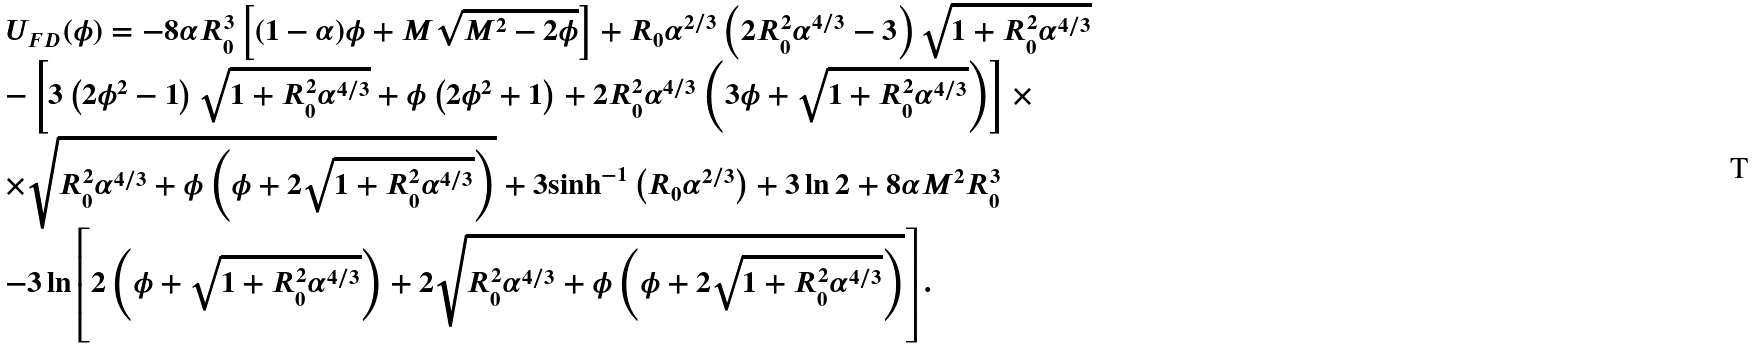Convert formula to latex. <formula><loc_0><loc_0><loc_500><loc_500>\begin{array} { l } { U _ { F D } } ( \phi ) = - 8 \alpha { R _ { 0 } ^ { 3 } } \left [ { ( 1 - \alpha ) \phi + M \sqrt { { M ^ { 2 } } - 2 \phi } } \right ] + R _ { 0 } { \alpha ^ { 2 / 3 } } \left ( { 2 { R _ { 0 } ^ { 2 } } { \alpha ^ { 4 / 3 } } - 3 } \right ) \sqrt { 1 + { R _ { 0 } ^ { 2 } } { \alpha ^ { 4 / 3 } } } \\ - \left [ { 3 \left ( { 2 { \phi ^ { 2 } } - 1 } \right ) \sqrt { 1 + { R _ { 0 } ^ { 2 } } { \alpha ^ { 4 / 3 } } } + \phi \left ( { 2 { \phi ^ { 2 } } + 1 } \right ) + 2 { R _ { 0 } ^ { 2 } } { \alpha ^ { 4 / 3 } } \left ( { 3 \phi + \sqrt { 1 + { R _ { 0 } ^ { 2 } } { \alpha ^ { 4 / 3 } } } } \right ) } \right ] \times \\ \times \sqrt { { R _ { 0 } ^ { 2 } } { \alpha ^ { 4 / 3 } } + \phi \left ( { \phi + 2 \sqrt { 1 + { R _ { 0 } ^ { 2 } } { \alpha ^ { 4 / 3 } } } } \right ) } + 3 { \sinh ^ { - 1 } } \left ( { R _ { 0 } { \alpha ^ { 2 / 3 } } } \right ) + 3 \ln 2 + 8 \alpha { M ^ { 2 } } R _ { 0 } ^ { 3 } \\ - 3 \ln \left [ { 2 \left ( { \phi + \sqrt { 1 + { R _ { 0 } ^ { 2 } } { \alpha ^ { 4 / 3 } } } } \right ) + 2 \sqrt { { R _ { 0 } ^ { 2 } } { \alpha ^ { 4 / 3 } } + \phi \left ( { \phi + 2 \sqrt { 1 + { R _ { 0 } ^ { 2 } } { \alpha ^ { 4 / 3 } } } } \right ) } } \right ] . \\ \end{array}</formula> 